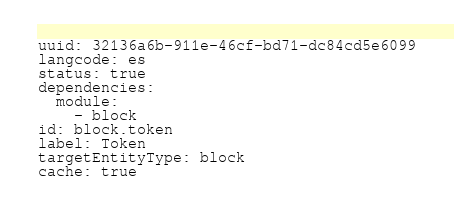Convert code to text. <code><loc_0><loc_0><loc_500><loc_500><_YAML_>uuid: 32136a6b-911e-46cf-bd71-dc84cd5e6099
langcode: es
status: true
dependencies:
  module:
    - block
id: block.token
label: Token
targetEntityType: block
cache: true
</code> 